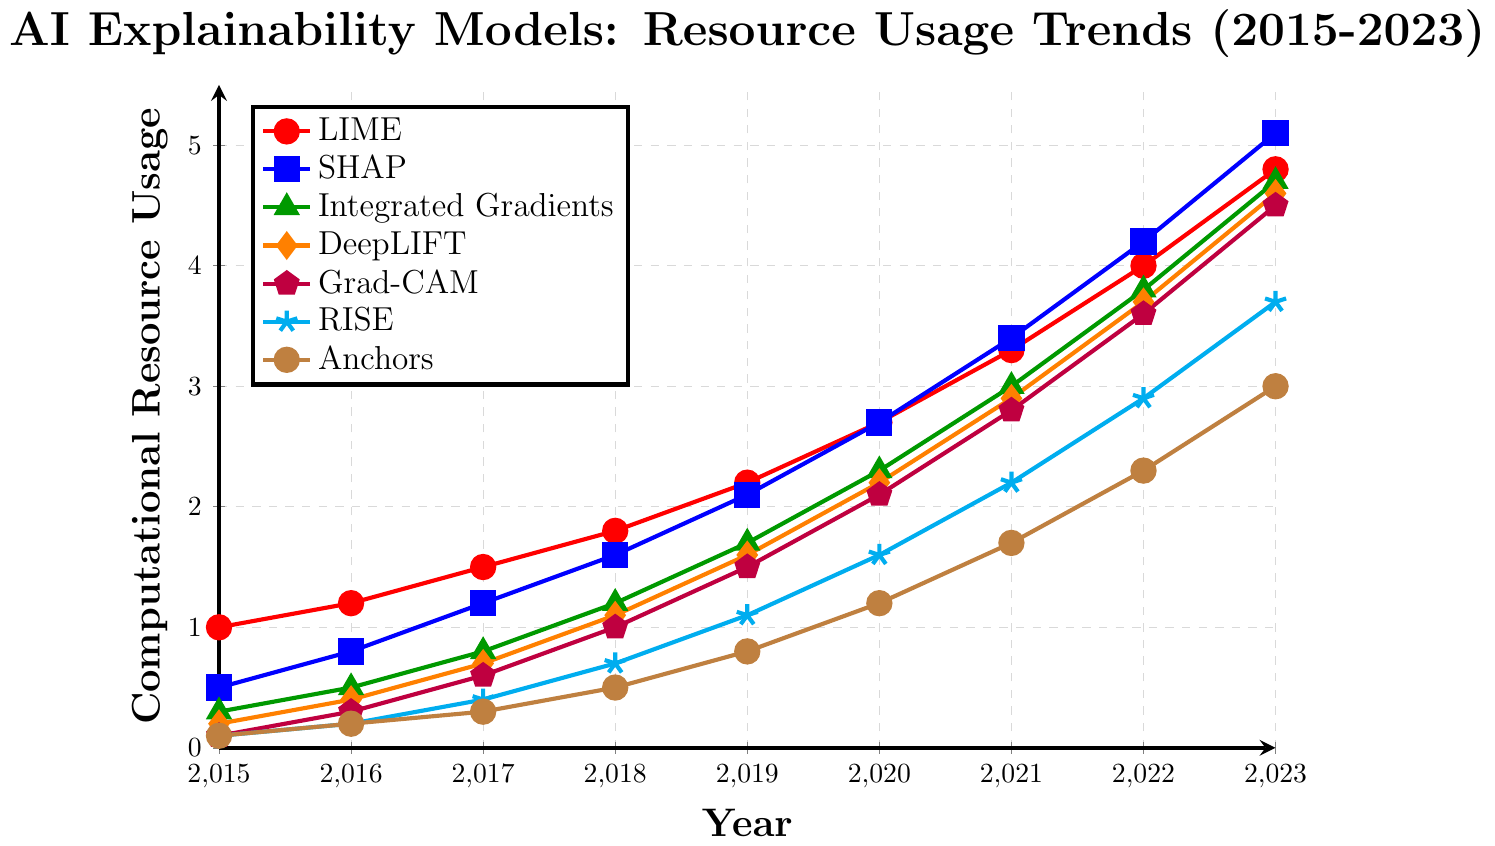What is the trend of computational resource usage for the LIME model from 2015 to 2023? The trend can be observed by looking at the line representing LIME (red with circle markers) on the plot. The computational resource usage for LIME is steadily increasing every year from 1.0 in 2015 to 4.8 in 2023.
Answer: Steadily increasing Which model had the highest computational resource usage in 2023? To find this, look for the highest y-value in 2023 across all models. The SHAP model (represented by blue squares) has a value of 5.1, which is the highest in 2023.
Answer: SHAP Between SHAP and Grad-CAM, which model experienced a larger increase in computational resource usage from 2015 to 2023? We calculate the difference for both models: SHAP increased from 0.5 to 5.1 (a 4.6 increase), and Grad-CAM increased from 0.1 to 4.5 (a 4.4 increase). Therefore, SHAP experienced a larger increase.
Answer: SHAP What is the average computational resource usage for the Integrated Gradients model over the nine years? Add the values from 2015 to 2023 and divide by 9: (0.3 + 0.5 + 0.8 + 1.2 + 1.7 + 2.3 + 3.0 + 3.8 + 4.7) / 9 = 18.3 / 9 = 2.033.
Answer: 2.033 Which year saw the highest increase in resource usage for the RISE model? Calculate the yearly differences for RISE from 2015 to 2023: 
2016-2015 (0.2 - 0.1 = 0.1), 
2017-2016 (0.4 - 0.2 = 0.2), 
2018-2017 (0.7 - 0.4 = 0.3), 
2019-2018 (1.1 - 0.7 = 0.4),
2020-2019 (1.6 - 1.1 = 0.5), 
2021-2020 (2.2 - 1.6 = 0.6), 
2022-2021 (2.9 - 2.2 = 0.7), 
2023-2022 (3.7 - 2.9 = 0.8). The highest increase occurred between 2022 and 2023 with an increase of 0.8.
Answer: 2022-2023 How does the computational resource usage of the Anchors model in 2020 compare to that of the Grad-CAM model in the same year? Look at the values for 2020: Anchors is 1.2, and Grad-CAM is 2.1. So, Grad-CAM uses more computational resources in 2020.
Answer: Grad-CAM What is the median value of the DeepLIFT model's computational resource usage from 2015 to 2023? Arrange the values in order from low to high: [0.2, 0.4, 0.7, 1.1, 1.6, 2.2, 2.9, 3.7, 4.6]. The middle value (fifth one) is 1.6.
Answer: 1.6 In which year did SHAP's computational resource usage first exceed that of LIME? Compare SHAP and LIME values year by year until SHAP's value is greater: 
2015: SHAP (0.5) vs. LIME (1.0) – No
2016: SHAP (0.8) vs. LIME (1.2) – No
2017: SHAP (1.2) vs. LIME (1.5) – No
2018: SHAP (1.6) vs. LIME (1.8) – No
2019: SHAP (2.1) vs. LIME (2.2) – No
2020: SHAP (2.7) vs. LIME (2.7) – No
2021: SHAP (3.4) vs. LIME (3.3) – Yes, it exceeds in 2021.
Answer: 2021 